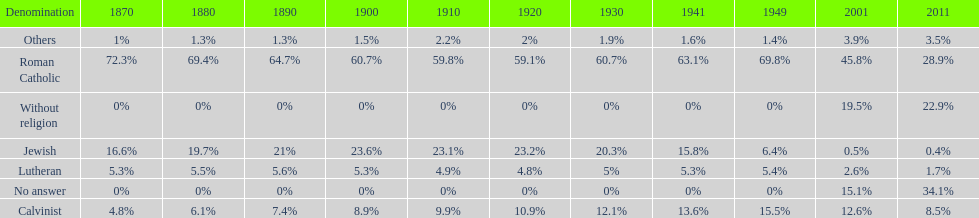Which denomination has the highest margin? Roman Catholic. 